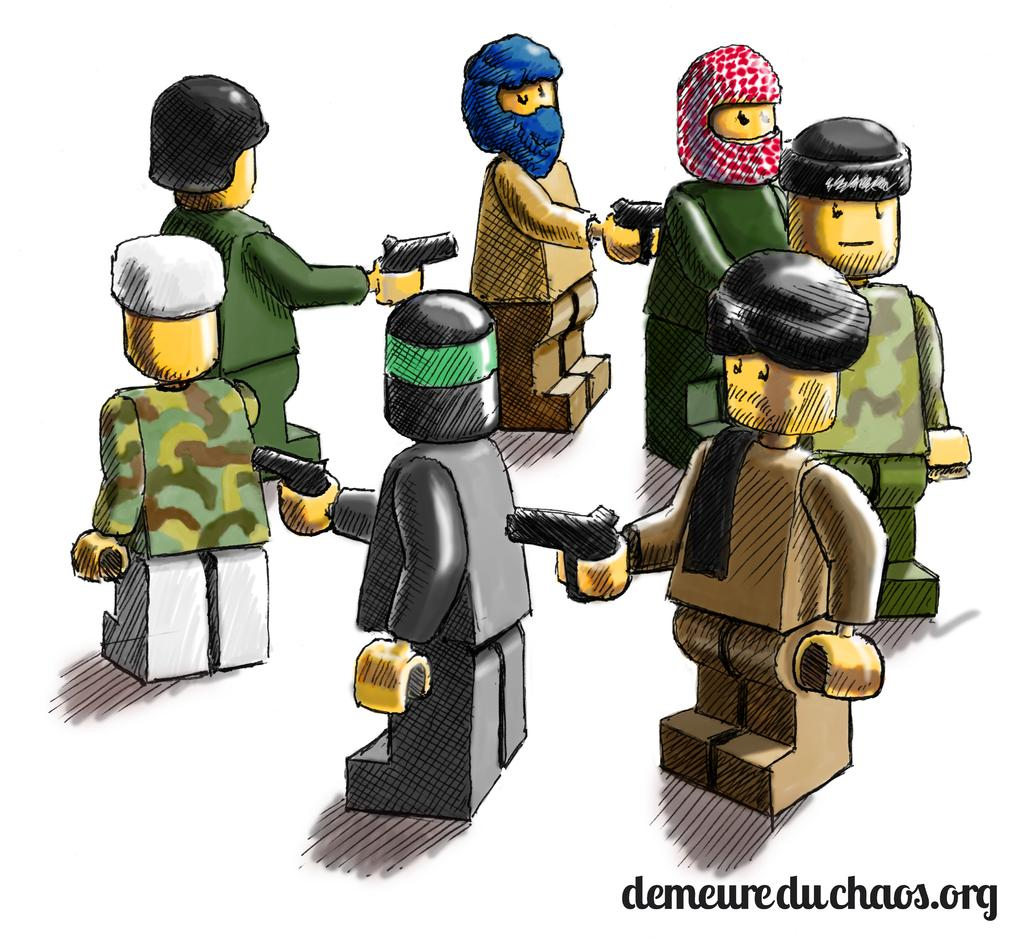What type of pictures are present in the image? There are animated pictures in the image. What are the animated pictures holding? The animated pictures are holding something. What color is the background of the image? The background of the image is white. Is there any text present in the image? Yes, there is text written on the image. Can you tell me how many slaves are depicted in the image? There are no slaves present in the image; it features animated pictures holding something. What type of creature is shown interacting with the animated pictures in the image? There is no creature shown interacting with the animated pictures in the image; only the animated pictures and text are present. 